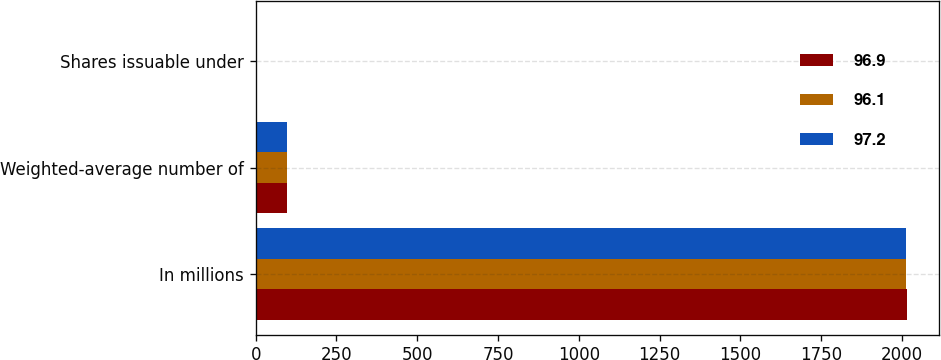<chart> <loc_0><loc_0><loc_500><loc_500><stacked_bar_chart><ecel><fcel>In millions<fcel>Weighted-average number of<fcel>Shares issuable under<nl><fcel>96.9<fcel>2015<fcel>96.9<fcel>1<nl><fcel>96.1<fcel>2014<fcel>97.2<fcel>1.1<nl><fcel>97.2<fcel>2013<fcel>96.1<fcel>0.1<nl></chart> 